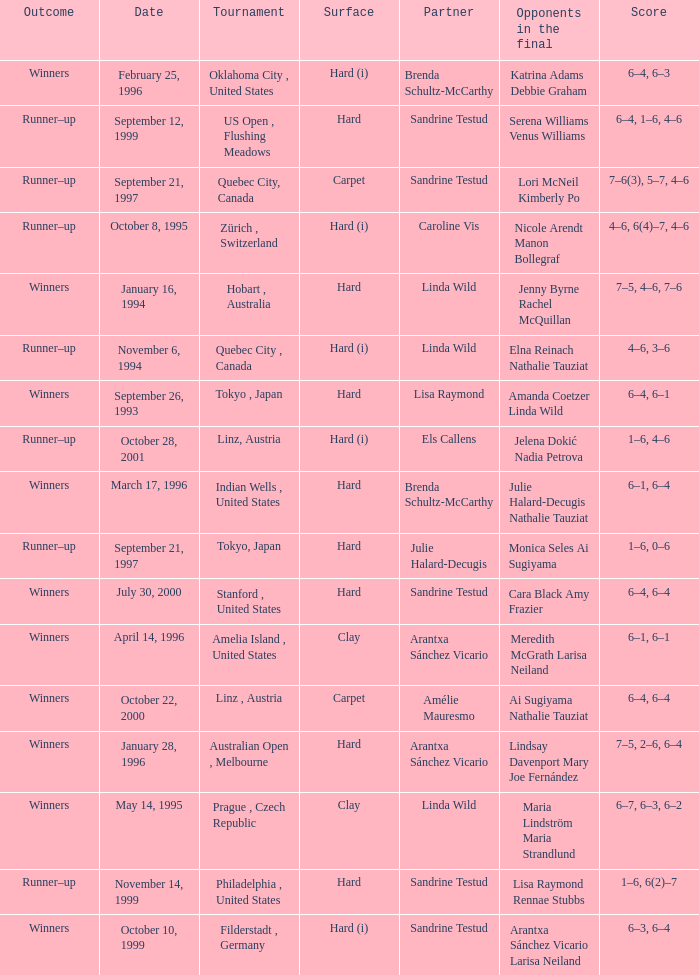Which surface had a partner of Sandrine Testud on November 14, 1999? Hard. 